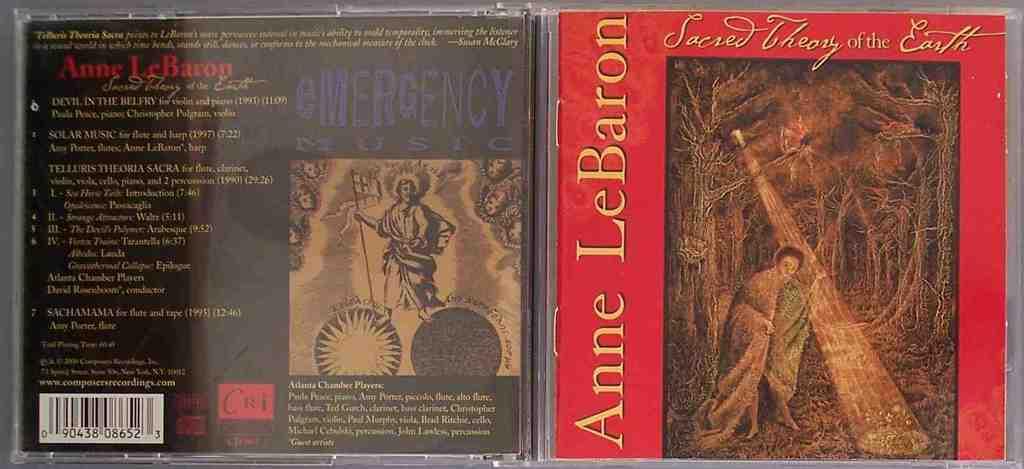Who wrote this album?
Your response must be concise. Anne lebaron. 